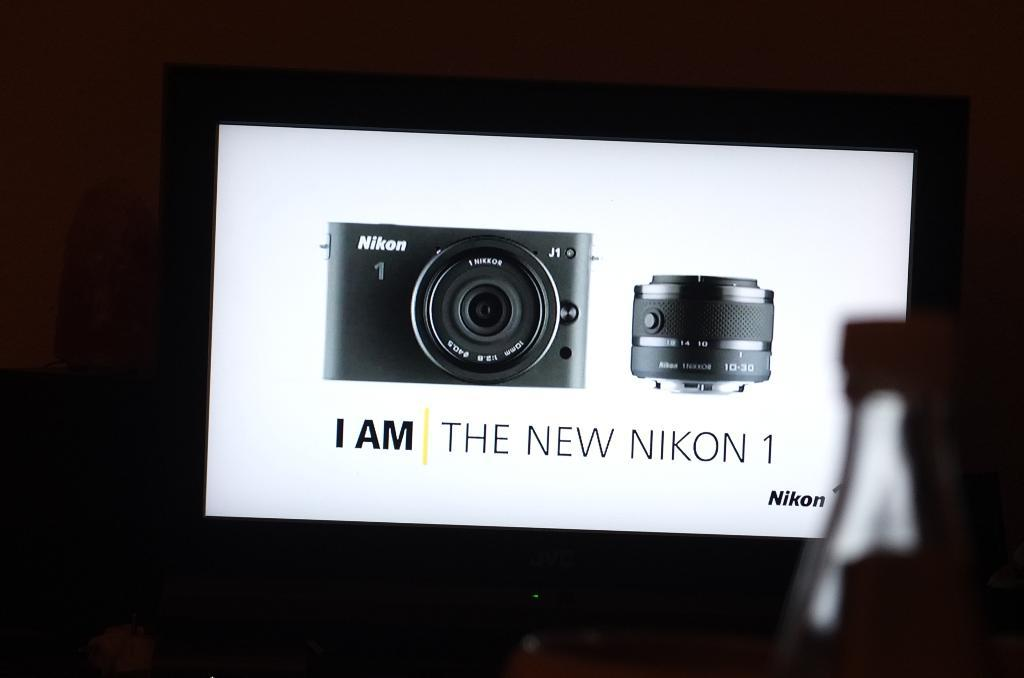What type of equipment is depicted in the images in the picture? There are pictures of a camera and a lens in the image. Where are these images displayed? The pictures are displayed on a screen. How many oranges are visible on the screen in the image? There are no oranges visible on the screen in the image; the pictures displayed are of a camera and a lens. Can you see a cow in the image? There is no cow present in the image; it only contains pictures of a camera and a lens displayed on a screen. 